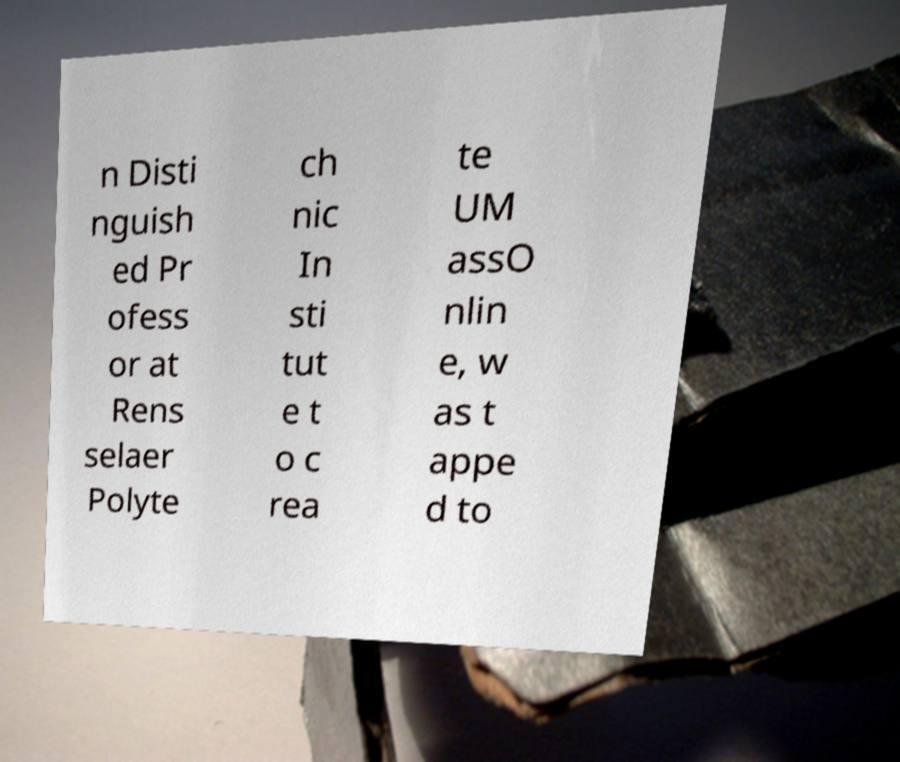Could you assist in decoding the text presented in this image and type it out clearly? n Disti nguish ed Pr ofess or at Rens selaer Polyte ch nic In sti tut e t o c rea te UM assO nlin e, w as t appe d to 